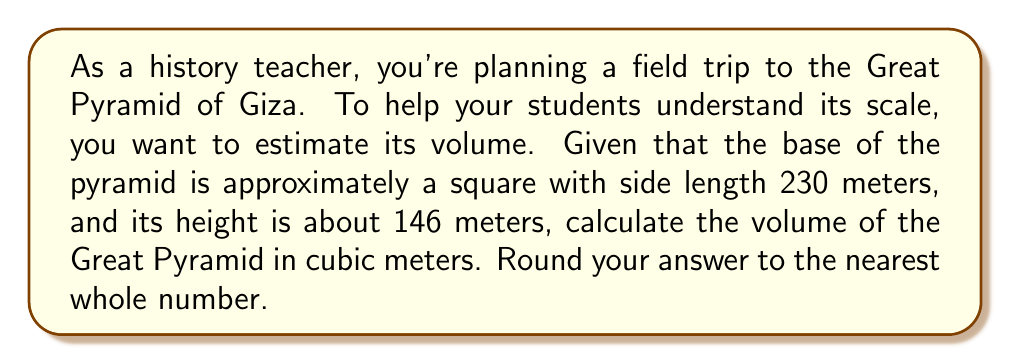Solve this math problem. Let's approach this step-by-step:

1) The formula for the volume of a pyramid is:

   $$V = \frac{1}{3} * B * h$$

   where $V$ is volume, $B$ is the area of the base, and $h$ is the height.

2) We're given that the base is a square with side length 230 meters. So, the area of the base is:

   $$B = 230^2 = 52,900 \text{ m}^2$$

3) The height $h$ is given as 146 meters.

4) Now, let's substitute these values into our volume formula:

   $$V = \frac{1}{3} * 52,900 * 146$$

5) Let's calculate:

   $$V = \frac{1}{3} * 7,723,400$$
   $$V = 2,574,466.67 \text{ m}^3$$

6) Rounding to the nearest whole number:

   $$V \approx 2,574,467 \text{ m}^3$$

[asy]
import geometry;

size(200);
pair A = (0,0), B = (100,0), C = (50,87);
draw(A--B--C--cycle);
draw(A--C,dashed);
label("230 m",B,S);
label("146 m",(50,0),S);
[/asy]
Answer: 2,574,467 m³ 